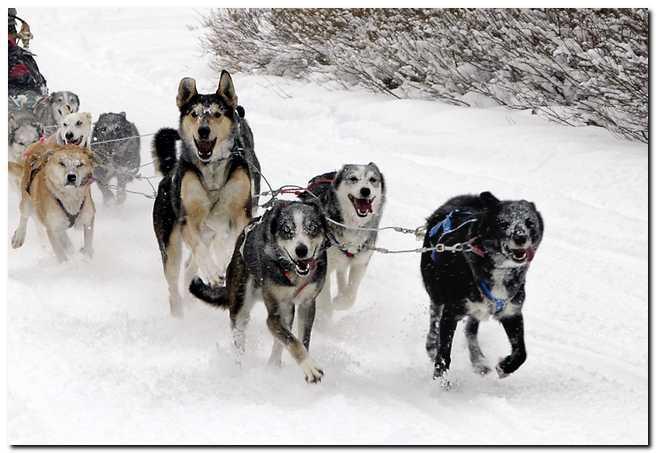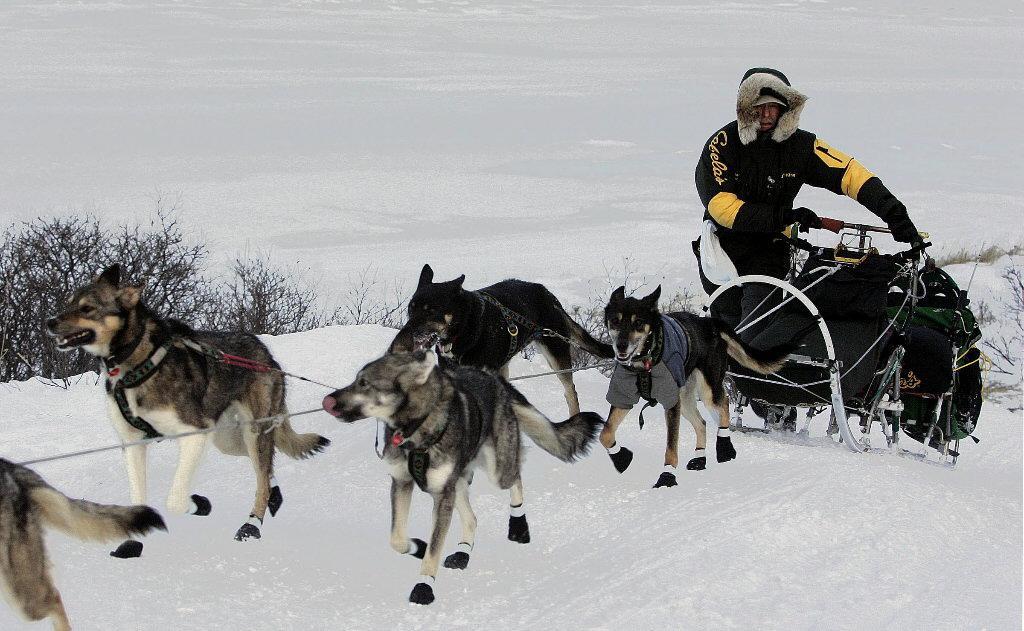The first image is the image on the left, the second image is the image on the right. Examine the images to the left and right. Is the description "Most of the dogs on one sled team are wearing black booties with a white band across the top." accurate? Answer yes or no. Yes. The first image is the image on the left, the second image is the image on the right. Considering the images on both sides, is "Most of the dogs in one of the images are wearing boots." valid? Answer yes or no. Yes. 